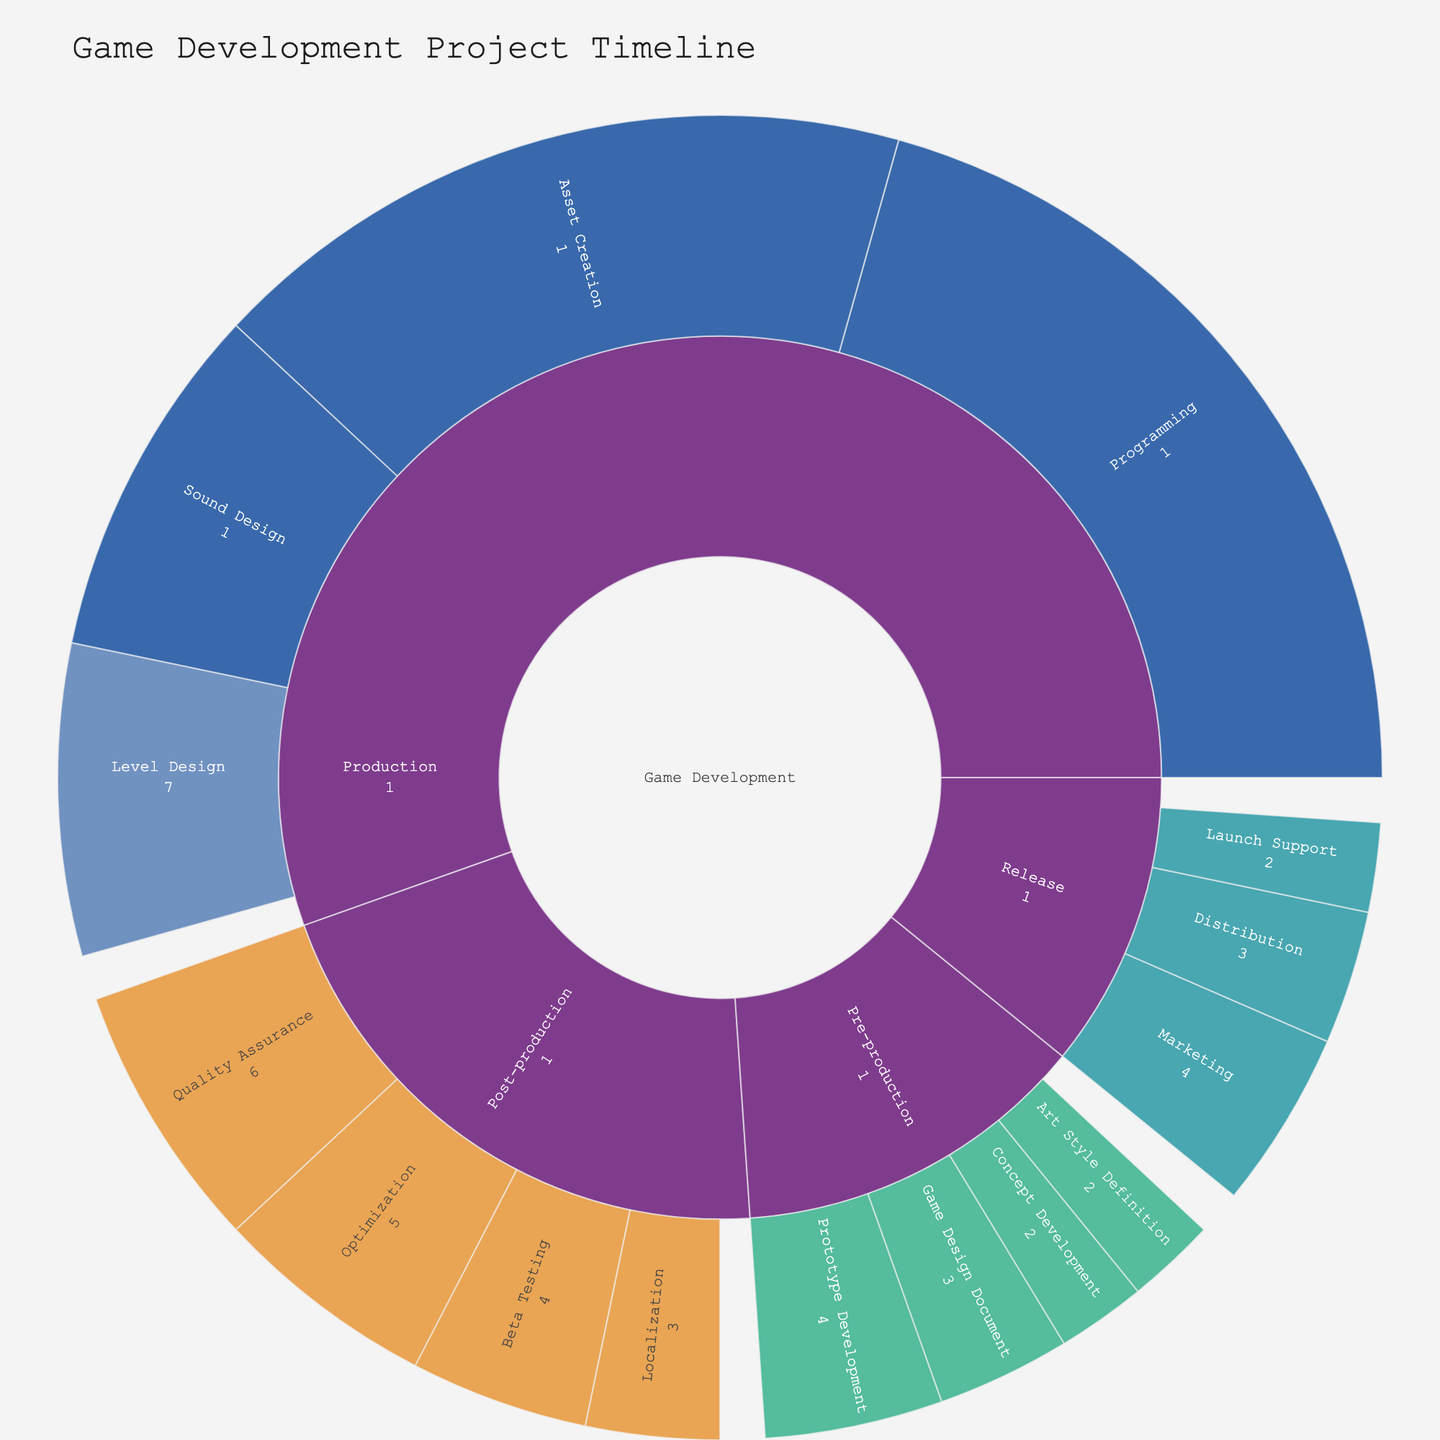What are the main phases of the game development project? The top level of the sunburst plot shows the main phases of the project which are connected directly to "Game Development". These are "Pre-production", "Production", "Post-production", and "Release".
Answer: Pre-production, Production, Post-production, Release Which task has the highest resource allocation in the production phase? Within the production phase, each segment represents different tasks with values indicating resource allocation. The largest segment is "Programming" with 18 units.
Answer: Programming How many units of resources are allocated to "Asset Creation"? "Asset Creation" is broken down into three tasks: 3D Modeling with 5 units, Texturing with 4 units, and Animation with 6 units. Summing them gives 5 + 4 + 6 = 15.
Answer: 15 What is the total resource allocation for the "Sound Design" tasks? "Sound Design" has two tasks: Music Composition and SFX Creation. Their resource values are 3 and 4, respectively. Adding them together gives 3 + 4 = 7.
Answer: 7 Compare the resource allocation of "Quality Assurance" and "Beta Testing" in the post-production phase. Which one has a higher allocation? "Quality Assurance" has 6 units and "Beta Testing" has 4 units. Comparing the two, "Quality Assurance" has a higher allocation.
Answer: Quality Assurance What's the difference in resource allocation between "Prototype Development" and "Localization"? "Prototype Development" allocates 4 units, while "Localization" allocates 3 units. The difference is 4 - 3 = 1.
Answer: 1 What is the combined resource allocation for the tasks in the "Programming" section? The programming section has three tasks: Core Mechanics (8), AI Development (6), and UI Implementation (4). Summing these gives 8+6+4 = 18.
Answer: 18 What's the value of the smallest task segment within the pre-production phase? The smallest tasks in "Pre-production" based on value are "Concept Development" and "Art Style Definition", both with 2 units each.
Answer: 2 